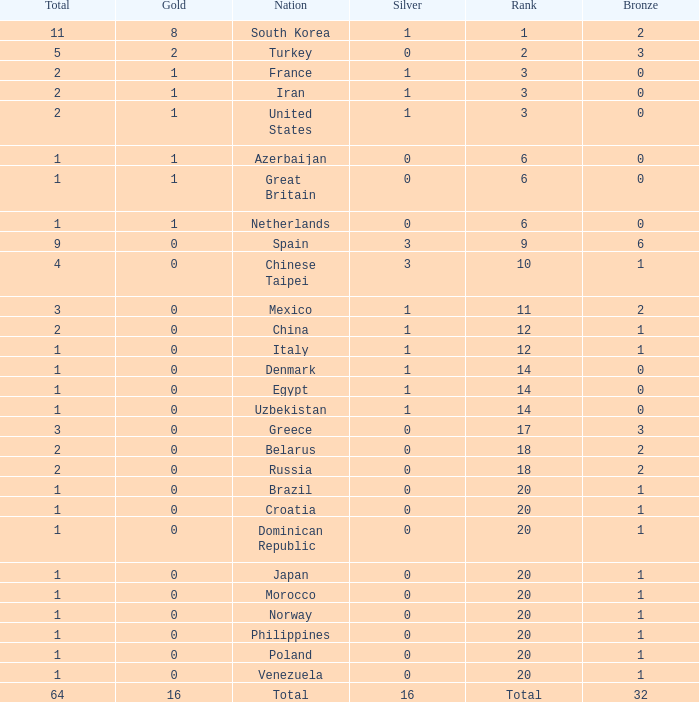What is the average total medals of the nation ranked 1 with less than 1 silver? None. 